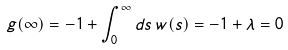<formula> <loc_0><loc_0><loc_500><loc_500>g ( \infty ) = - 1 + \int _ { 0 } ^ { \infty } d s \, w ( s ) = - 1 + \lambda = 0</formula> 